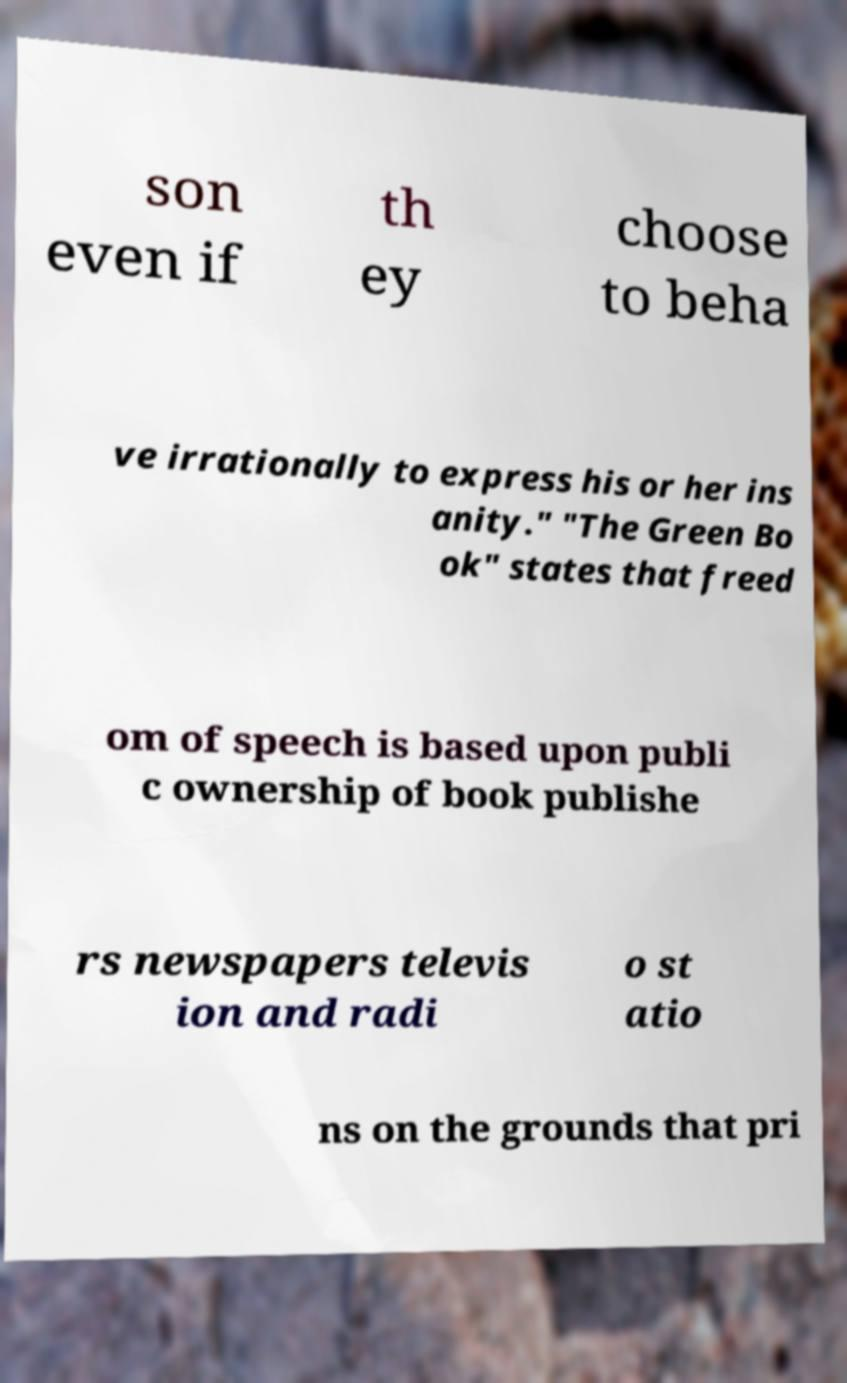Can you read and provide the text displayed in the image?This photo seems to have some interesting text. Can you extract and type it out for me? son even if th ey choose to beha ve irrationally to express his or her ins anity." "The Green Bo ok" states that freed om of speech is based upon publi c ownership of book publishe rs newspapers televis ion and radi o st atio ns on the grounds that pri 